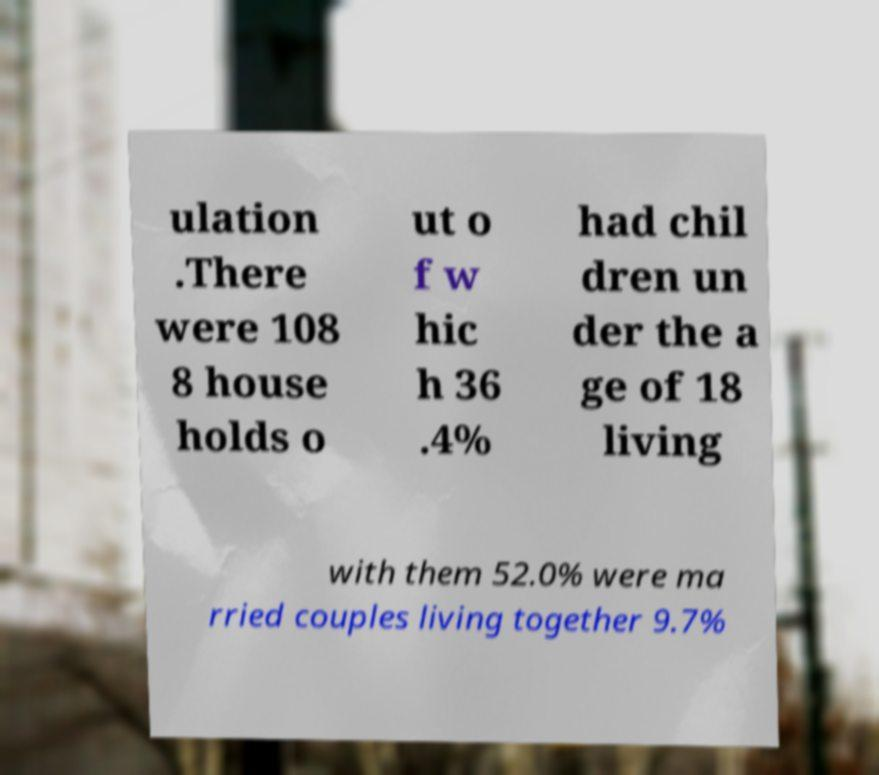There's text embedded in this image that I need extracted. Can you transcribe it verbatim? ulation .There were 108 8 house holds o ut o f w hic h 36 .4% had chil dren un der the a ge of 18 living with them 52.0% were ma rried couples living together 9.7% 